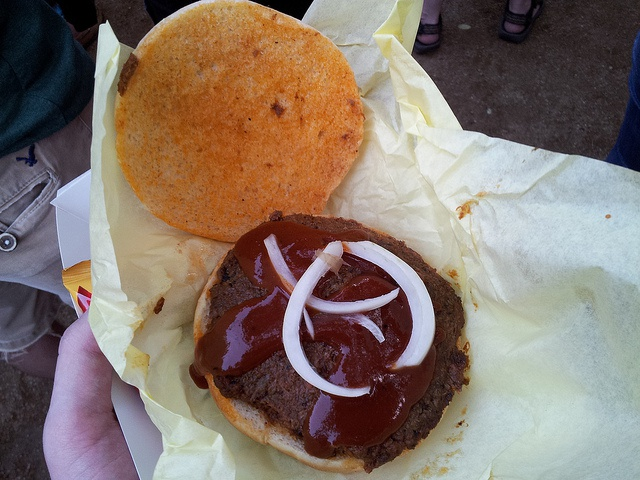Describe the objects in this image and their specific colors. I can see sandwich in black, maroon, lavender, and purple tones, people in black and gray tones, people in black, darkgray, purple, violet, and gray tones, and people in black and purple tones in this image. 